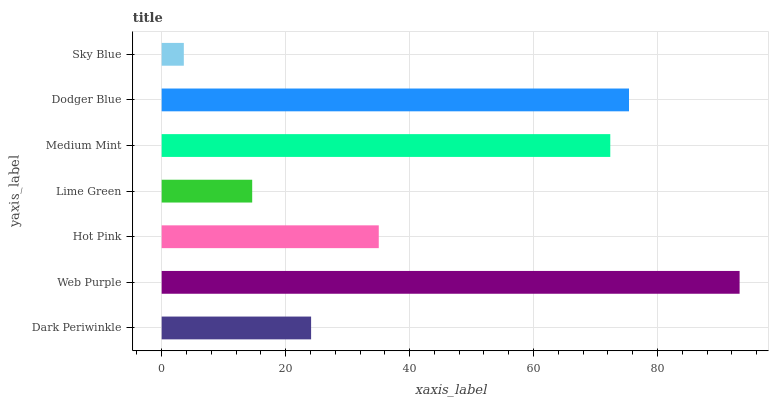Is Sky Blue the minimum?
Answer yes or no. Yes. Is Web Purple the maximum?
Answer yes or no. Yes. Is Hot Pink the minimum?
Answer yes or no. No. Is Hot Pink the maximum?
Answer yes or no. No. Is Web Purple greater than Hot Pink?
Answer yes or no. Yes. Is Hot Pink less than Web Purple?
Answer yes or no. Yes. Is Hot Pink greater than Web Purple?
Answer yes or no. No. Is Web Purple less than Hot Pink?
Answer yes or no. No. Is Hot Pink the high median?
Answer yes or no. Yes. Is Hot Pink the low median?
Answer yes or no. Yes. Is Dodger Blue the high median?
Answer yes or no. No. Is Dark Periwinkle the low median?
Answer yes or no. No. 